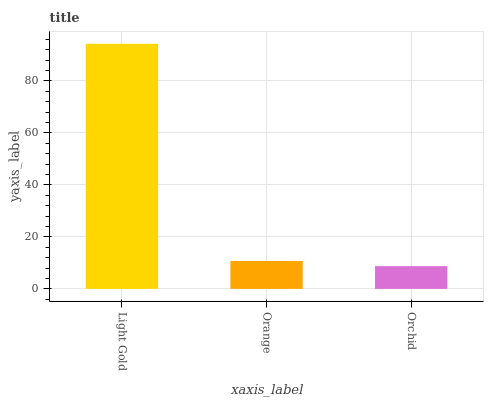Is Orchid the minimum?
Answer yes or no. Yes. Is Light Gold the maximum?
Answer yes or no. Yes. Is Orange the minimum?
Answer yes or no. No. Is Orange the maximum?
Answer yes or no. No. Is Light Gold greater than Orange?
Answer yes or no. Yes. Is Orange less than Light Gold?
Answer yes or no. Yes. Is Orange greater than Light Gold?
Answer yes or no. No. Is Light Gold less than Orange?
Answer yes or no. No. Is Orange the high median?
Answer yes or no. Yes. Is Orange the low median?
Answer yes or no. Yes. Is Light Gold the high median?
Answer yes or no. No. Is Orchid the low median?
Answer yes or no. No. 